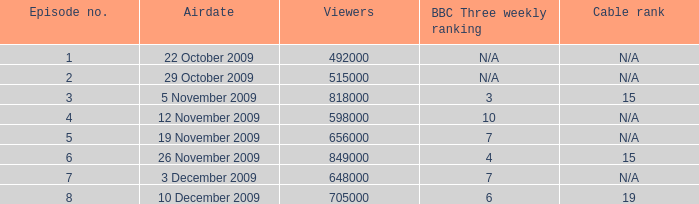How many entries are presented for viewers when the airdate was 26 november 2009? 1.0. 